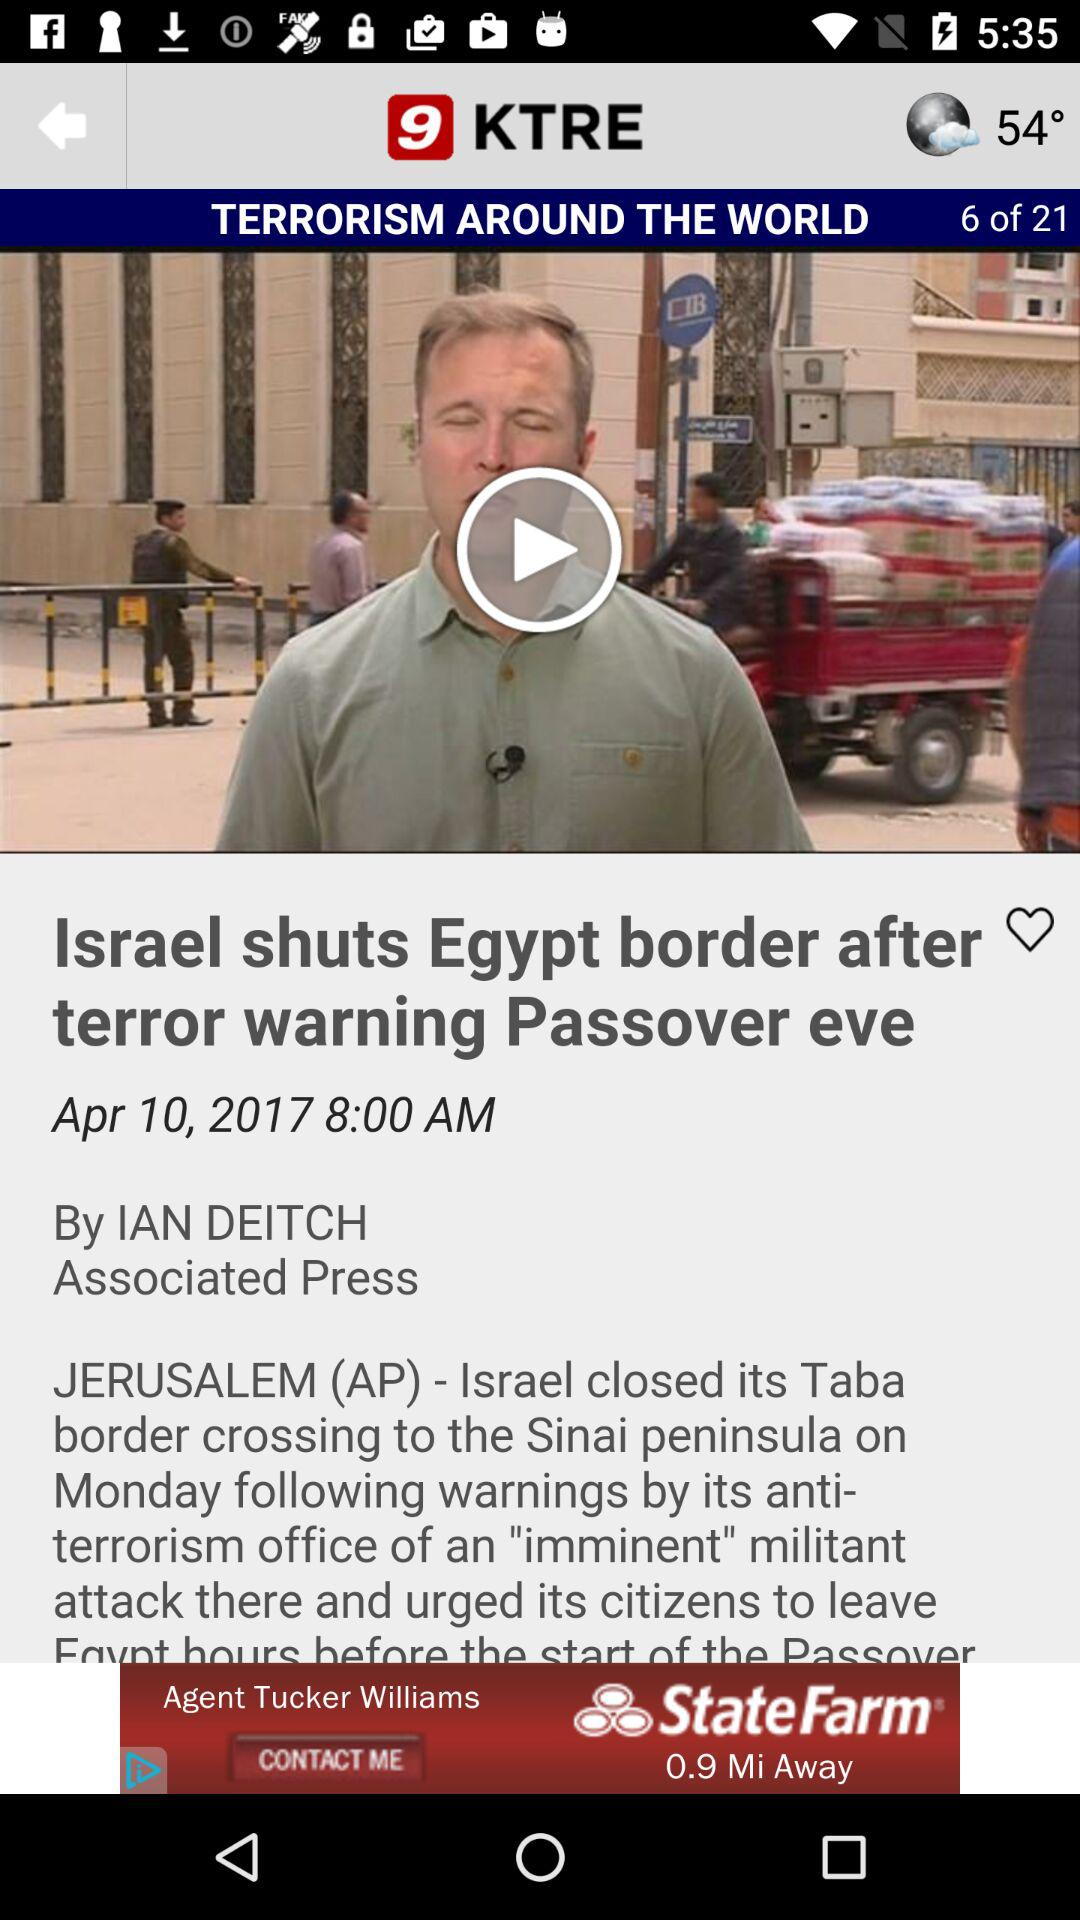What is the reporter's name? The reporter's name is "IAN DEITCH". 